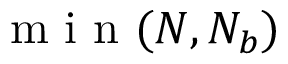Convert formula to latex. <formula><loc_0><loc_0><loc_500><loc_500>m i n ( N , N _ { b } )</formula> 